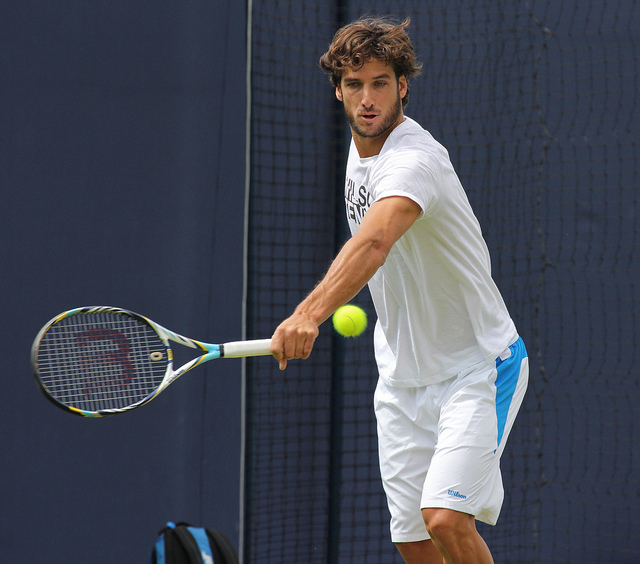What does the attire of the person suggest about the setting? The attire, consisting of a light-colored t-shirt and shorts, suggests an informal practice session or a warm-up. The clothing is suitable for athletic activity, allowing for mobility and comfort. Is this type of clothing standard for the activity shown? Yes, this type of clothing is standard for playing tennis. Players typically wear lightweight, breathable outfits that permit a full range of motion for swings and sprints. 